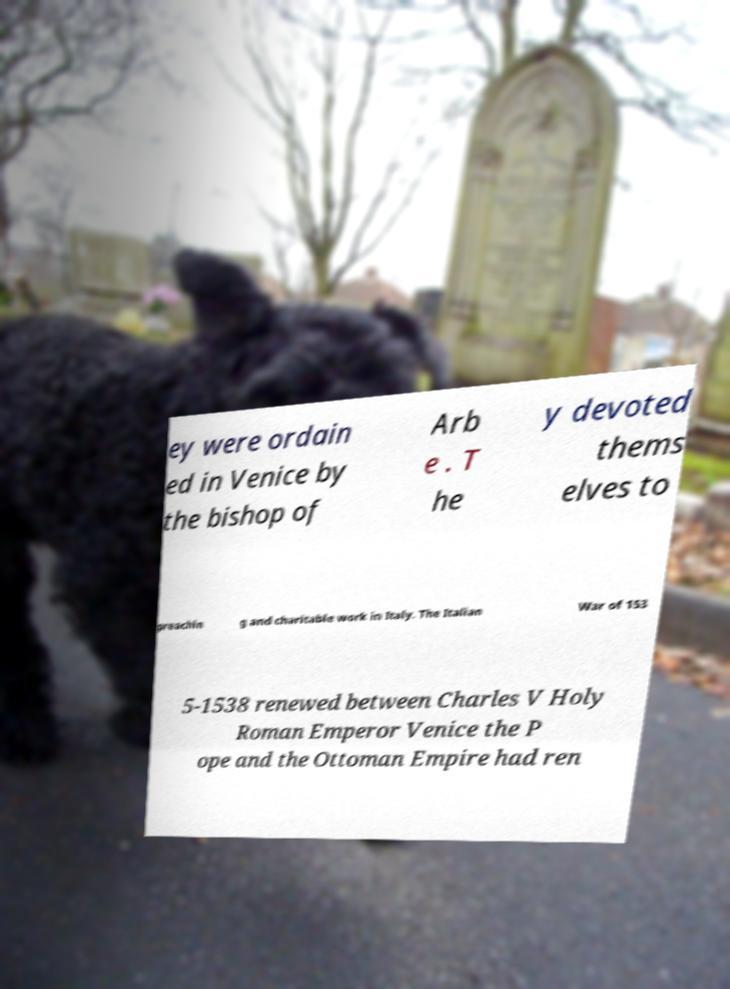Please read and relay the text visible in this image. What does it say? ey were ordain ed in Venice by the bishop of Arb e . T he y devoted thems elves to preachin g and charitable work in Italy. The Italian War of 153 5-1538 renewed between Charles V Holy Roman Emperor Venice the P ope and the Ottoman Empire had ren 